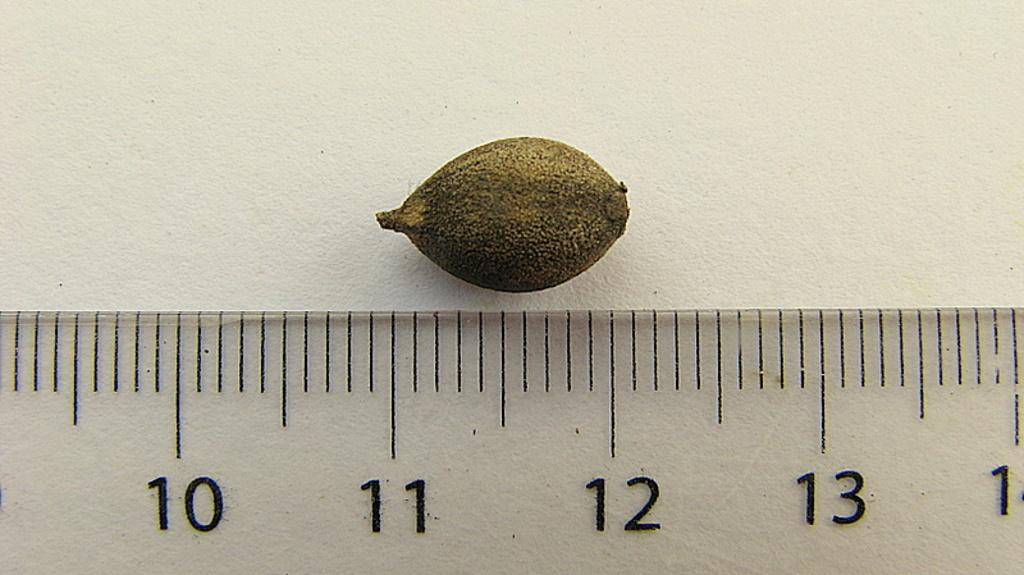<image>
Offer a succinct explanation of the picture presented. Some sort of a nut being measured against a ruler between 11 and 12. 